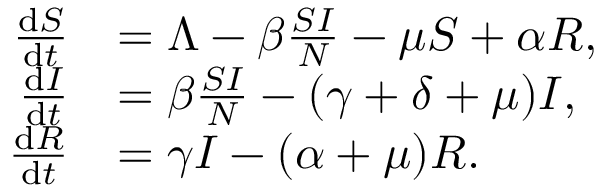<formula> <loc_0><loc_0><loc_500><loc_500>\begin{array} { r l } { \frac { d S } { d t } } & { = \Lambda - \beta \frac { S I } { N } - \mu S + \alpha R , } \\ { \frac { d I } { d t } } & { = \beta \frac { S I } { N } - ( \gamma + \delta + \mu ) I , } \\ { \frac { d R } { d t } } & { = \gamma I - ( \alpha + \mu ) R . } \end{array}</formula> 